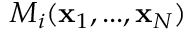Convert formula to latex. <formula><loc_0><loc_0><loc_500><loc_500>M _ { i } ( { x } _ { 1 } , \dots , { x } _ { N } )</formula> 